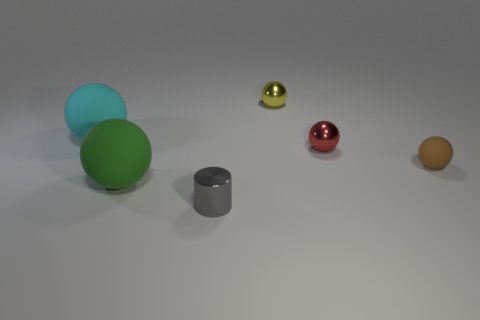Add 1 metal objects. How many objects exist? 7 Subtract all tiny yellow spheres. How many spheres are left? 4 Subtract all red balls. How many balls are left? 4 Subtract all balls. How many objects are left? 1 Subtract all yellow metal things. Subtract all small yellow things. How many objects are left? 4 Add 6 green spheres. How many green spheres are left? 7 Add 6 large green metal cylinders. How many large green metal cylinders exist? 6 Subtract 0 red cylinders. How many objects are left? 6 Subtract 2 balls. How many balls are left? 3 Subtract all red cylinders. Subtract all brown blocks. How many cylinders are left? 1 